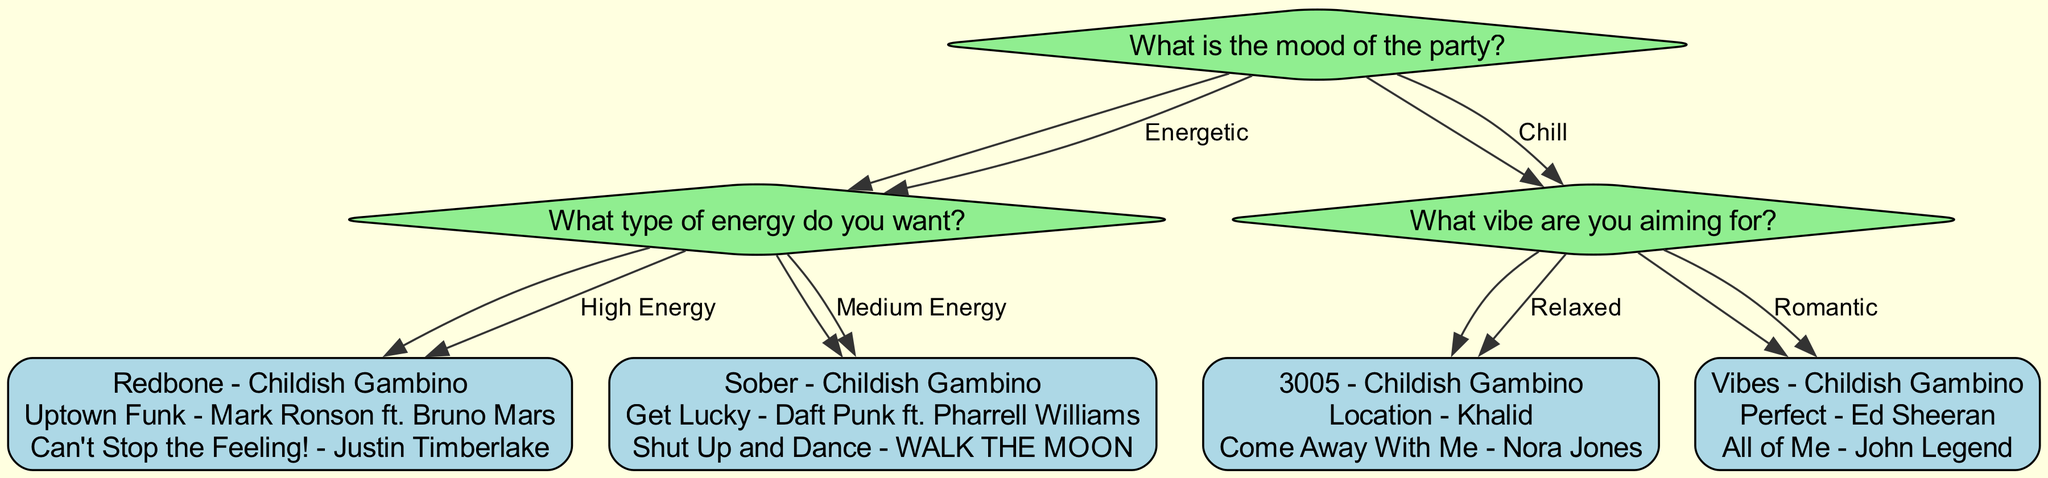What is the starting question in the decision tree? The starting question is displayed at the top of the diagram, which asks for the mood of the party.
Answer: What is the mood of the party? How many total songs are listed in the diagram? By counting the songs listed under each energy and vibe option, we find that there are 9 songs in total: 3 for High Energy, 3 for Medium Energy, 3 for Relaxed, and 3 for Romantic.
Answer: 12 What is the next question if the mood of the party is Chill? If the mood is Chill, the next question asked is about what vibe the person is aiming for.
Answer: What vibe are you aiming for? Which song is recommended for High Energy? Under the High Energy option, one of the songs listed is "Redbone - Childish Gambino."
Answer: Redbone - Childish Gambino How many options are available if the mood is Chill? For the Chill mood, there are two options available: Relaxed and Romantic, leading to a total of two pathways in the decision tree.
Answer: 2 If someone chooses Medium Energy as their option, which songs will they see? The decision tree specifies that selecting Medium Energy leads to three songs: "Sober - Childish Gambino," "Get Lucky - Daft Punk ft. Pharrell Williams," and "Shut Up and Dance - WALK THE MOON."
Answer: Sober - Childish Gambino, Get Lucky - Daft Punk ft. Pharrell Williams, Shut Up and Dance - WALK THE MOON What are two factors considered in the decision tree for making a song choice? The decision tree considers two main factors: Mood and Energy level. Specifically, it first addresses the mood (Energetic or Chill) and then the energy (High Energy or Medium Energy) as sub-factors.
Answer: Mood and Energy level What are the song options if someone selects Romantic? The Romantic option leads to three specific song recommendations: "Vibes - Childish Gambino," "Perfect - Ed Sheeran," and "All of Me - John Legend."
Answer: Vibes - Childish Gambino, Perfect - Ed Sheeran, All of Me - John Legend 